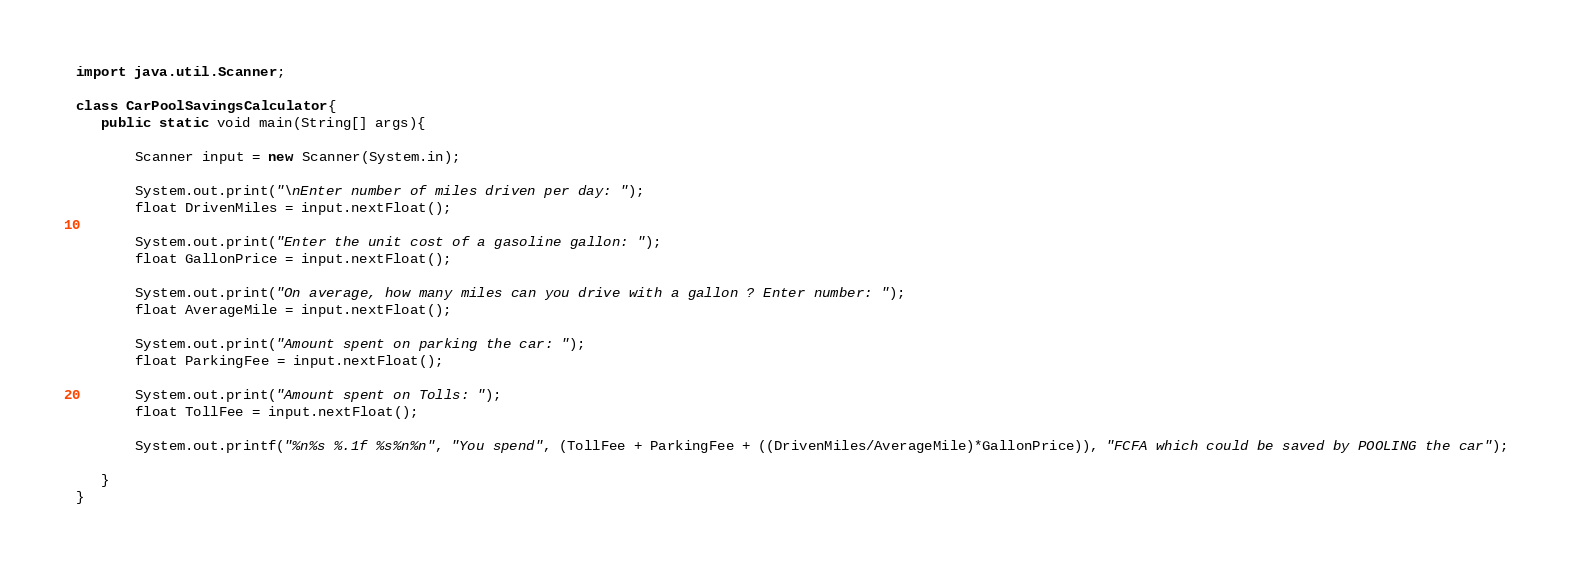<code> <loc_0><loc_0><loc_500><loc_500><_Java_>import java.util.Scanner;

class CarPoolSavingsCalculator{
   public static void main(String[] args){
       
       Scanner input = new Scanner(System.in);
       
       System.out.print("\nEnter number of miles driven per day: ");
       float DrivenMiles = input.nextFloat();
       
       System.out.print("Enter the unit cost of a gasoline gallon: ");
       float GallonPrice = input.nextFloat();
       
       System.out.print("On average, how many miles can you drive with a gallon ? Enter number: ");
       float AverageMile = input.nextFloat();
       
       System.out.print("Amount spent on parking the car: ");
       float ParkingFee = input.nextFloat();
       
       System.out.print("Amount spent on Tolls: ");
       float TollFee = input.nextFloat();
       
       System.out.printf("%n%s %.1f %s%n%n", "You spend", (TollFee + ParkingFee + ((DrivenMiles/AverageMile)*GallonPrice)), "FCFA which could be saved by POOLING the car");
       
   }
}
</code> 